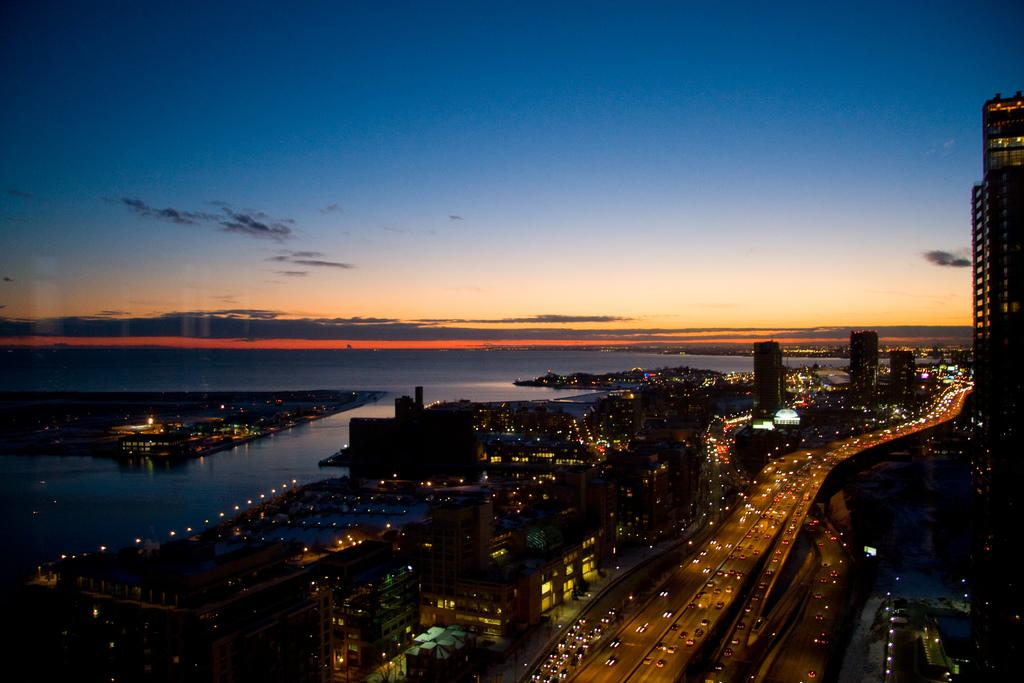What type of view is provided in the image? The image is a top view. What can be seen in the middle of the image? There is a road in the middle of the image. What structures are located on the right side of the image? There are buildings on the right side of the image. What natural feature is on the left side of the image? There is water on the left side of the image. What is visible at the top of the image? The sky is visible at the top of the image. Where is the berry located in the image? There is no berry present in the image. What type of slip can be seen on the road in the image? There is no slip visible on the road in the image. 